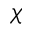Convert formula to latex. <formula><loc_0><loc_0><loc_500><loc_500>\chi</formula> 